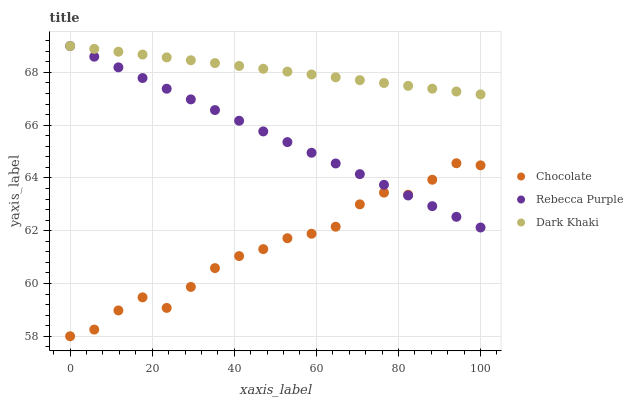Does Chocolate have the minimum area under the curve?
Answer yes or no. Yes. Does Dark Khaki have the maximum area under the curve?
Answer yes or no. Yes. Does Rebecca Purple have the minimum area under the curve?
Answer yes or no. No. Does Rebecca Purple have the maximum area under the curve?
Answer yes or no. No. Is Rebecca Purple the smoothest?
Answer yes or no. Yes. Is Chocolate the roughest?
Answer yes or no. Yes. Is Chocolate the smoothest?
Answer yes or no. No. Is Rebecca Purple the roughest?
Answer yes or no. No. Does Chocolate have the lowest value?
Answer yes or no. Yes. Does Rebecca Purple have the lowest value?
Answer yes or no. No. Does Rebecca Purple have the highest value?
Answer yes or no. Yes. Does Chocolate have the highest value?
Answer yes or no. No. Is Chocolate less than Dark Khaki?
Answer yes or no. Yes. Is Dark Khaki greater than Chocolate?
Answer yes or no. Yes. Does Rebecca Purple intersect Chocolate?
Answer yes or no. Yes. Is Rebecca Purple less than Chocolate?
Answer yes or no. No. Is Rebecca Purple greater than Chocolate?
Answer yes or no. No. Does Chocolate intersect Dark Khaki?
Answer yes or no. No. 